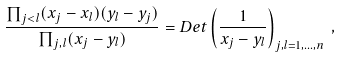<formula> <loc_0><loc_0><loc_500><loc_500>\frac { \prod _ { j < l } ( x _ { j } - x _ { l } ) ( y _ { l } - y _ { j } ) } { \prod _ { j , l } ( x _ { j } - y _ { l } ) } = D e t \left ( \frac { 1 } { x _ { j } - y _ { l } } \right ) _ { j , l = 1 , \dots , n } \, ,</formula> 